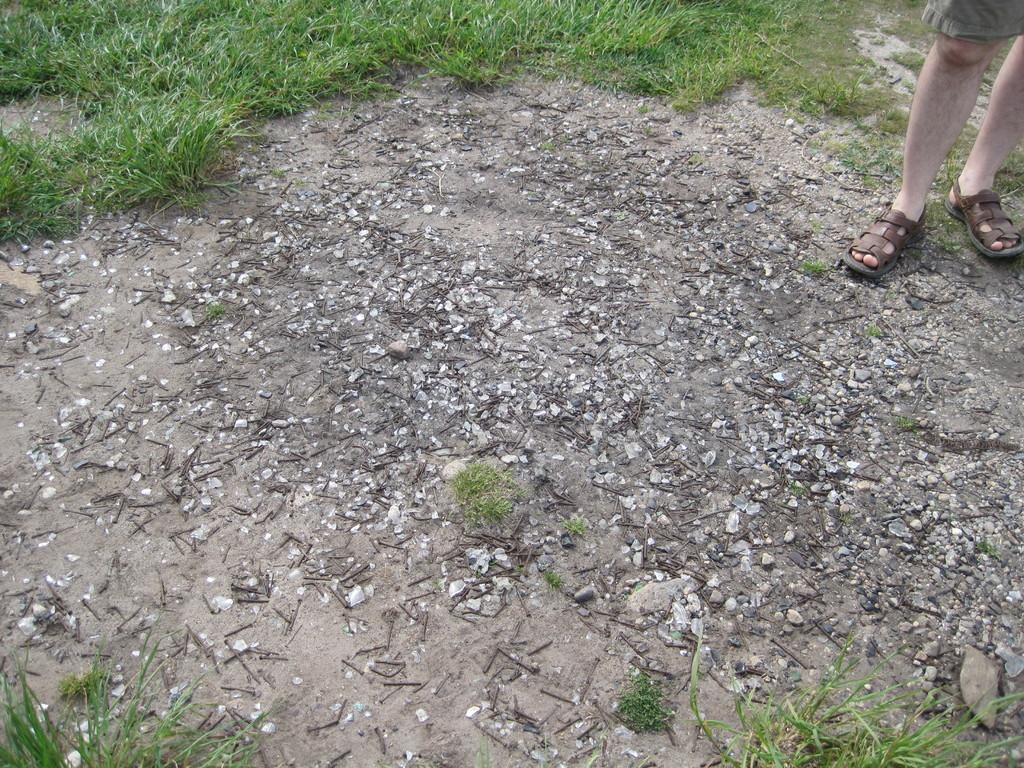What is at the bottom of the image? There is sand at the bottom of the image. What objects are on the sand? There are iron nails on the sand. Where is the person located in the image? The person is standing on the right side of the image. What type of vegetation is present in the image? There is grass in the image. What type of cake is being served on the left side of the image? There is no cake present in the image; it features sand, iron nails, a person, and grass. How does the person plan to embark on their voyage in the image? The image does not depict a voyage or any travel-related activities, so it is not possible to answer that question. 